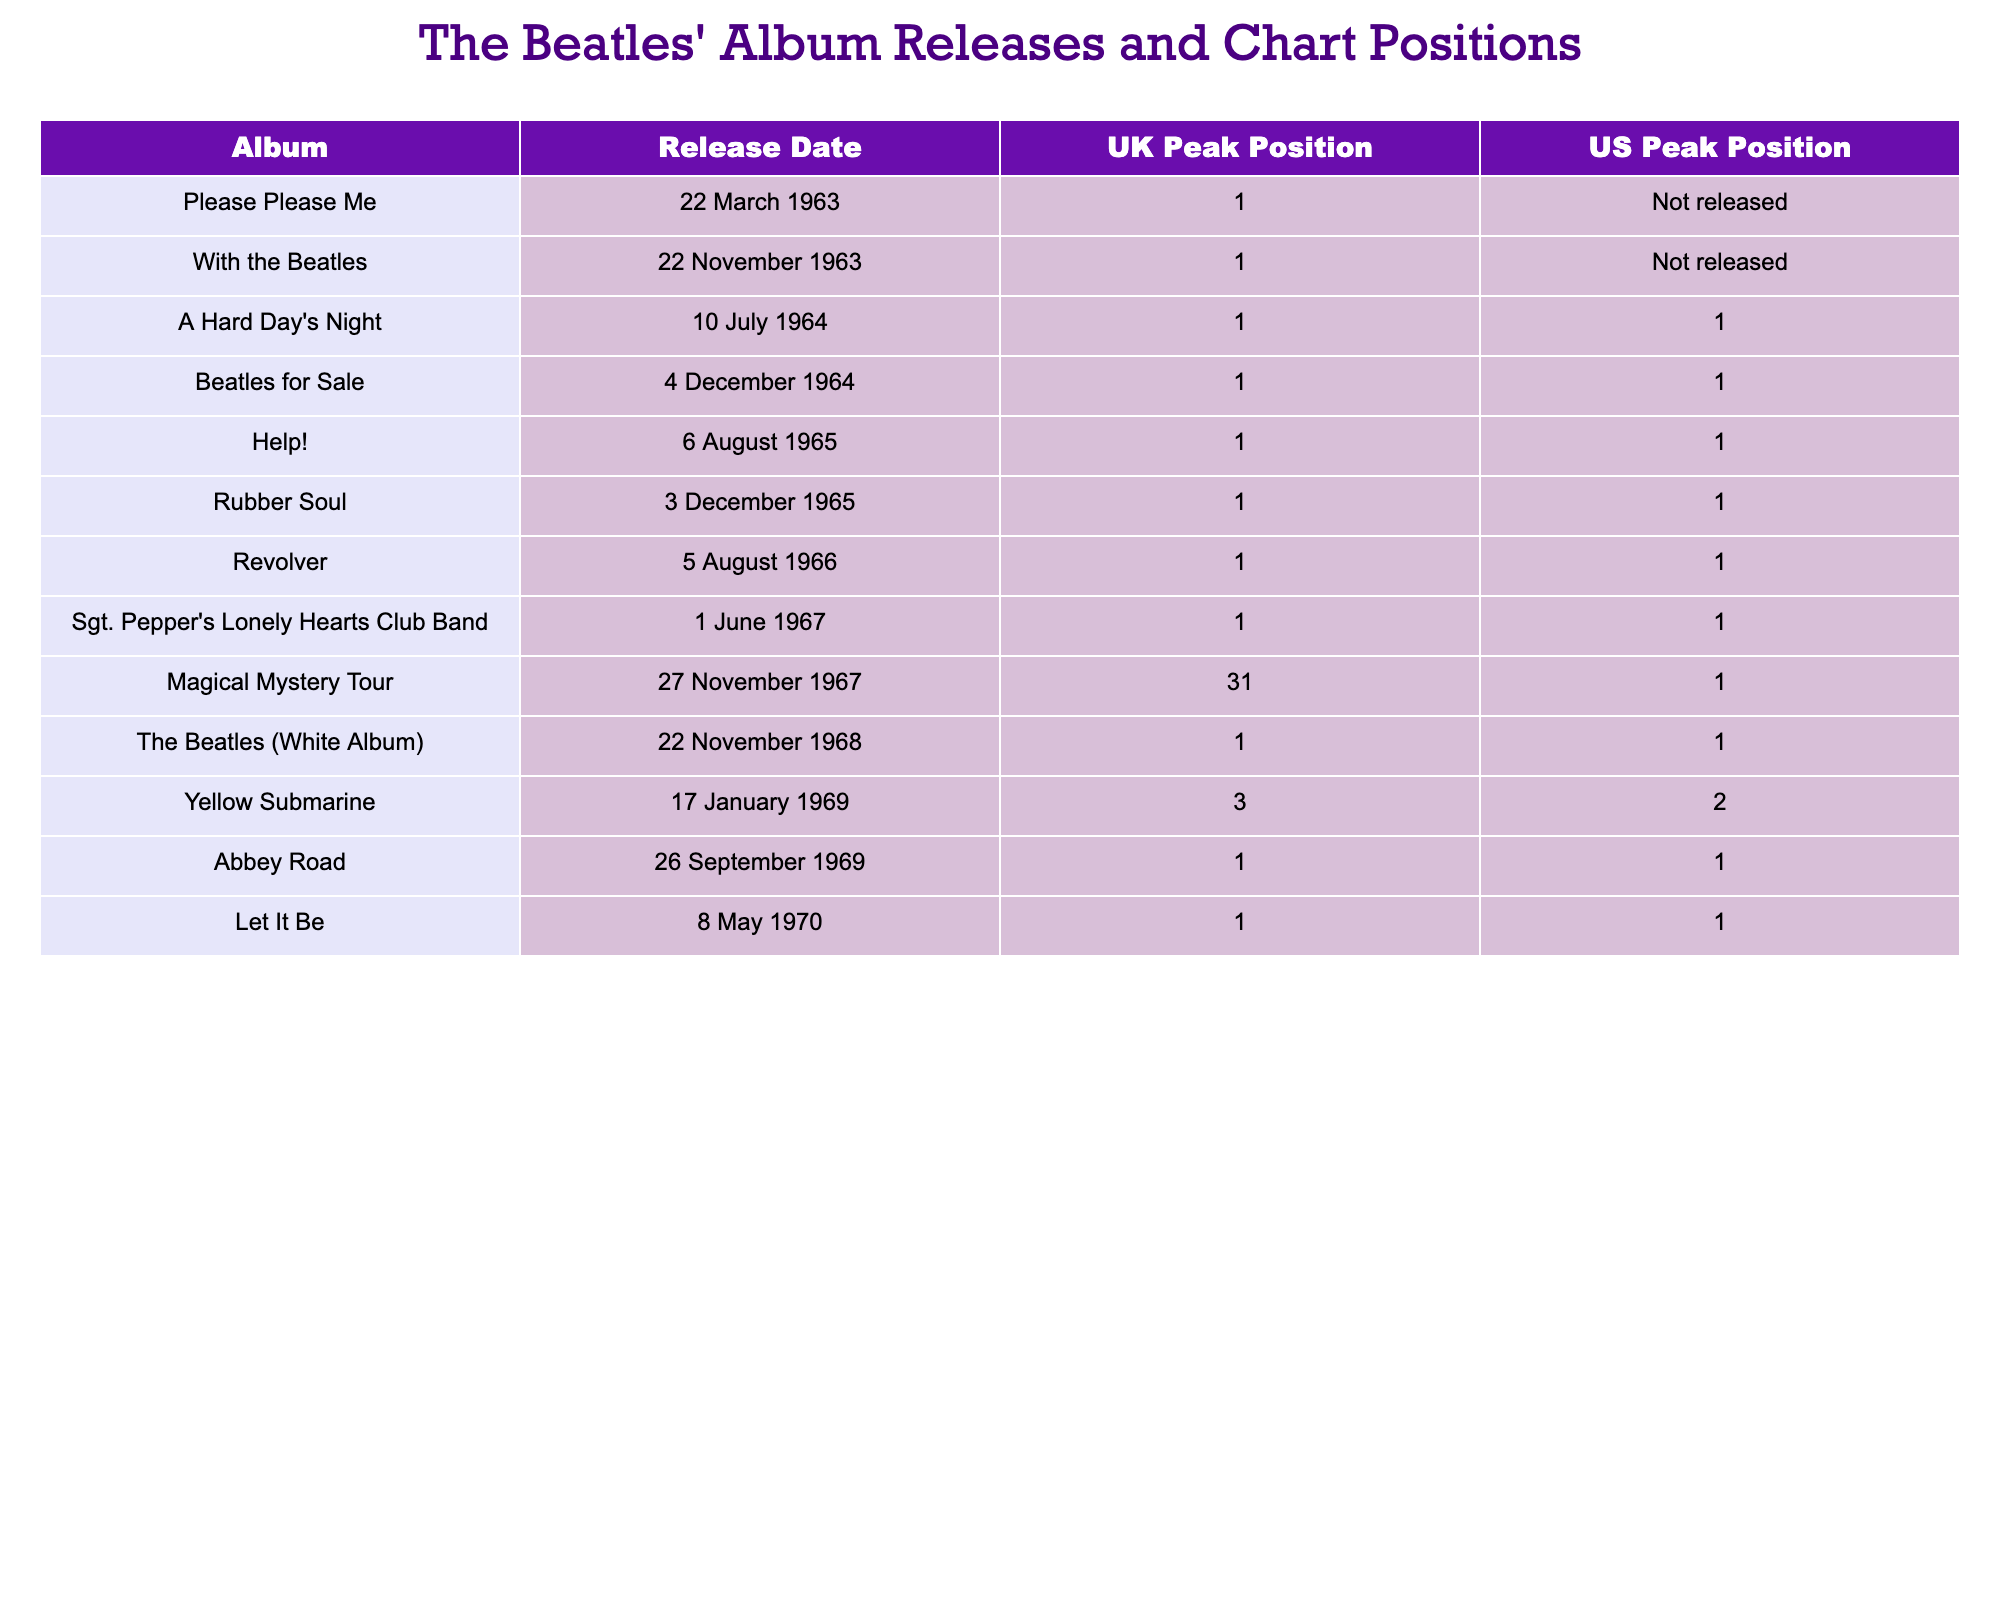What was the release date of "Sgt. Pepper's Lonely Hearts Club Band"? The table lists the release dates for each album, and "Sgt. Pepper's Lonely Hearts Club Band" is shown with its release date as 1 June 1967.
Answer: 1 June 1967 Which album had the highest peak position in both the UK and the US? The table shows that "A Hard Day's Night," "Beatles for Sale," "Help!," "Rubber Soul," "Revolver," "Sgt. Pepper's Lonely Hearts Club Band," "The Beatles (White Album)," "Abbey Road," and "Let It Be" all peaked at position 1 in both the UK and the US.
Answer: 9 albums How many albums reached the top position in the UK? By counting the unique albums listed in the UK section with a peak position of 1, we find that 11 albums achieved this status.
Answer: 11 Did "Magical Mystery Tour" peak at number 1 in the US? According to the table, "Magical Mystery Tour" reached a peak position of 31 in the US, which is not number 1.
Answer: No How many total albums listed had a peak position of 1 in the US? By reviewing the table, the albums that reached number 1 in the US are "A Hard Day's Night," "Beatles for Sale," "Help!," "Rubber Soul," "Revolver," "Sgt. Pepper's Lonely Hearts Club Band," "The Beatles (White Album)," "Abbey Road," and "Let It Be." This totals 8 albums.
Answer: 8 What is the difference in UK peak position between "Yellow Submarine" and "A Hard Day's Night"? "Yellow Submarine" peaked at position 3 while "A Hard Day's Night" peaked at position 1. The difference is calculated as 3 - 1 = 2.
Answer: 2 Which album was released first: "Please Please Me" or "Help!"? From the table, "Please Please Me" was released on 22 March 1963, and "Help!" was released on 6 August 1965, indicating that "Please Please Me" was released first.
Answer: Please Please Me What percentage of albums listed peaked at number 1 in the UK? There are 13 albums in total, and 11 of them peaked at number 1 in the UK. The percentage is calculated as (11/13) * 100 = approximately 84.6%.
Answer: 84.6% Which album held the same peak position in both the UK and US? The albums that peaked at number 1 in both the UK and the US are "A Hard Day's Night," "Beatles for Sale," "Help!," "Rubber Soul," "Revolver," "Sgt. Pepper's Lonely Hearts Club Band," "The Beatles (White Album)," "Abbey Road," and "Let It Be." Thus, there are 9 albums that meet this criterion.
Answer: 9 albums Is there any album released after "Magical Mystery Tour" that peaked at number 1 in the UK? The album “The Beatles (White Album)” was released on 22 November 1968, which is after "Magical Mystery Tour," and it peaked at number 1 in the UK.
Answer: Yes 